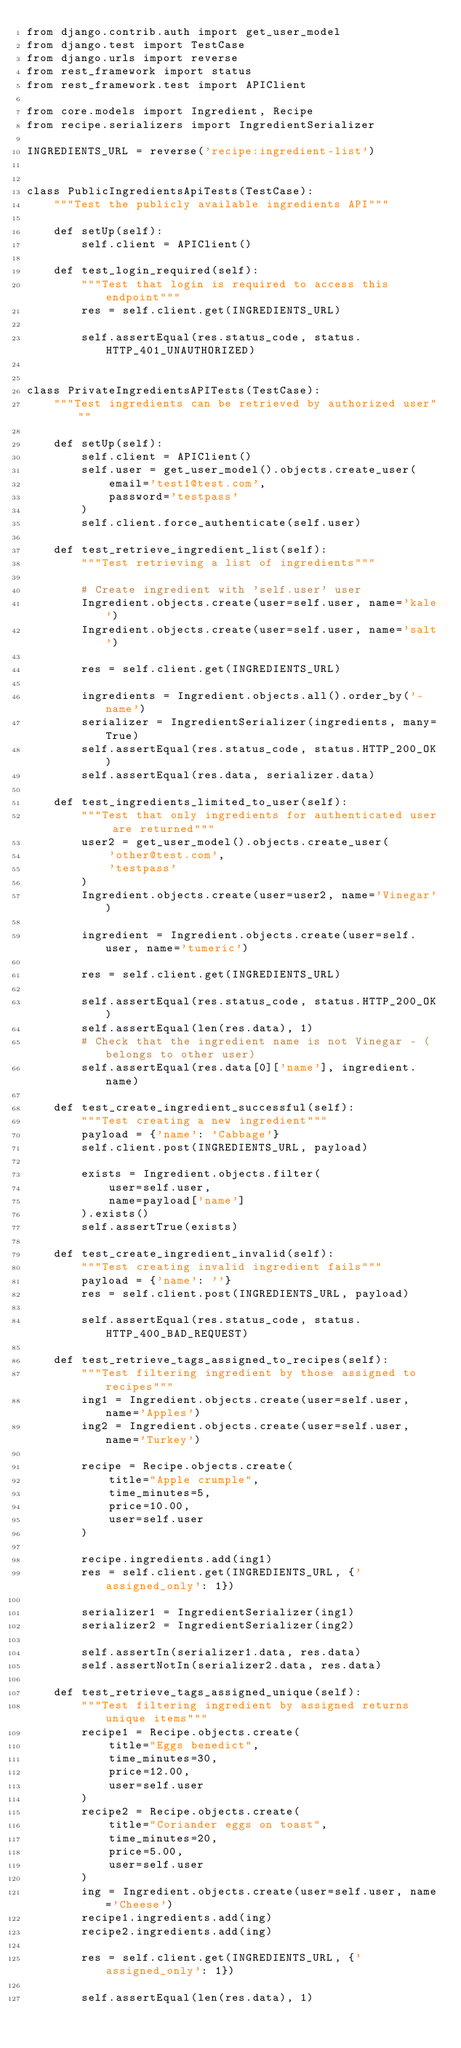Convert code to text. <code><loc_0><loc_0><loc_500><loc_500><_Python_>from django.contrib.auth import get_user_model
from django.test import TestCase
from django.urls import reverse
from rest_framework import status
from rest_framework.test import APIClient

from core.models import Ingredient, Recipe
from recipe.serializers import IngredientSerializer

INGREDIENTS_URL = reverse('recipe:ingredient-list')


class PublicIngredientsApiTests(TestCase):
    """Test the publicly available ingredients API"""

    def setUp(self):
        self.client = APIClient()

    def test_login_required(self):
        """Test that login is required to access this endpoint"""
        res = self.client.get(INGREDIENTS_URL)

        self.assertEqual(res.status_code, status.HTTP_401_UNAUTHORIZED)


class PrivateIngredientsAPITests(TestCase):
    """Test ingredients can be retrieved by authorized user"""

    def setUp(self):
        self.client = APIClient()
        self.user = get_user_model().objects.create_user(
            email='test1@test.com',
            password='testpass'
        )
        self.client.force_authenticate(self.user)

    def test_retrieve_ingredient_list(self):
        """Test retrieving a list of ingredients"""

        # Create ingredient with 'self.user' user
        Ingredient.objects.create(user=self.user, name='kale')
        Ingredient.objects.create(user=self.user, name='salt')

        res = self.client.get(INGREDIENTS_URL)

        ingredients = Ingredient.objects.all().order_by('-name')
        serializer = IngredientSerializer(ingredients, many=True)
        self.assertEqual(res.status_code, status.HTTP_200_OK)
        self.assertEqual(res.data, serializer.data)

    def test_ingredients_limited_to_user(self):
        """Test that only ingredients for authenticated user are returned"""
        user2 = get_user_model().objects.create_user(
            'other@test.com',
            'testpass'
        )
        Ingredient.objects.create(user=user2, name='Vinegar')

        ingredient = Ingredient.objects.create(user=self.user, name='tumeric')

        res = self.client.get(INGREDIENTS_URL)

        self.assertEqual(res.status_code, status.HTTP_200_OK)
        self.assertEqual(len(res.data), 1)
        # Check that the ingredient name is not Vinegar - (belongs to other user)
        self.assertEqual(res.data[0]['name'], ingredient.name)

    def test_create_ingredient_successful(self):
        """Test creating a new ingredient"""
        payload = {'name': 'Cabbage'}
        self.client.post(INGREDIENTS_URL, payload)

        exists = Ingredient.objects.filter(
            user=self.user,
            name=payload['name']
        ).exists()
        self.assertTrue(exists)

    def test_create_ingredient_invalid(self):
        """Test creating invalid ingredient fails"""
        payload = {'name': ''}
        res = self.client.post(INGREDIENTS_URL, payload)

        self.assertEqual(res.status_code, status.HTTP_400_BAD_REQUEST)

    def test_retrieve_tags_assigned_to_recipes(self):
        """Test filtering ingredient by those assigned to recipes"""
        ing1 = Ingredient.objects.create(user=self.user, name='Apples')
        ing2 = Ingredient.objects.create(user=self.user, name='Turkey')

        recipe = Recipe.objects.create(
            title="Apple crumple",
            time_minutes=5,
            price=10.00,
            user=self.user
        )

        recipe.ingredients.add(ing1)
        res = self.client.get(INGREDIENTS_URL, {'assigned_only': 1})

        serializer1 = IngredientSerializer(ing1)
        serializer2 = IngredientSerializer(ing2)

        self.assertIn(serializer1.data, res.data)
        self.assertNotIn(serializer2.data, res.data)

    def test_retrieve_tags_assigned_unique(self):
        """Test filtering ingredient by assigned returns unique items"""
        recipe1 = Recipe.objects.create(
            title="Eggs benedict",
            time_minutes=30,
            price=12.00,
            user=self.user
        )
        recipe2 = Recipe.objects.create(
            title="Coriander eggs on toast",
            time_minutes=20,
            price=5.00,
            user=self.user
        )
        ing = Ingredient.objects.create(user=self.user, name='Cheese')
        recipe1.ingredients.add(ing)
        recipe2.ingredients.add(ing)

        res = self.client.get(INGREDIENTS_URL, {'assigned_only': 1})

        self.assertEqual(len(res.data), 1)
</code> 